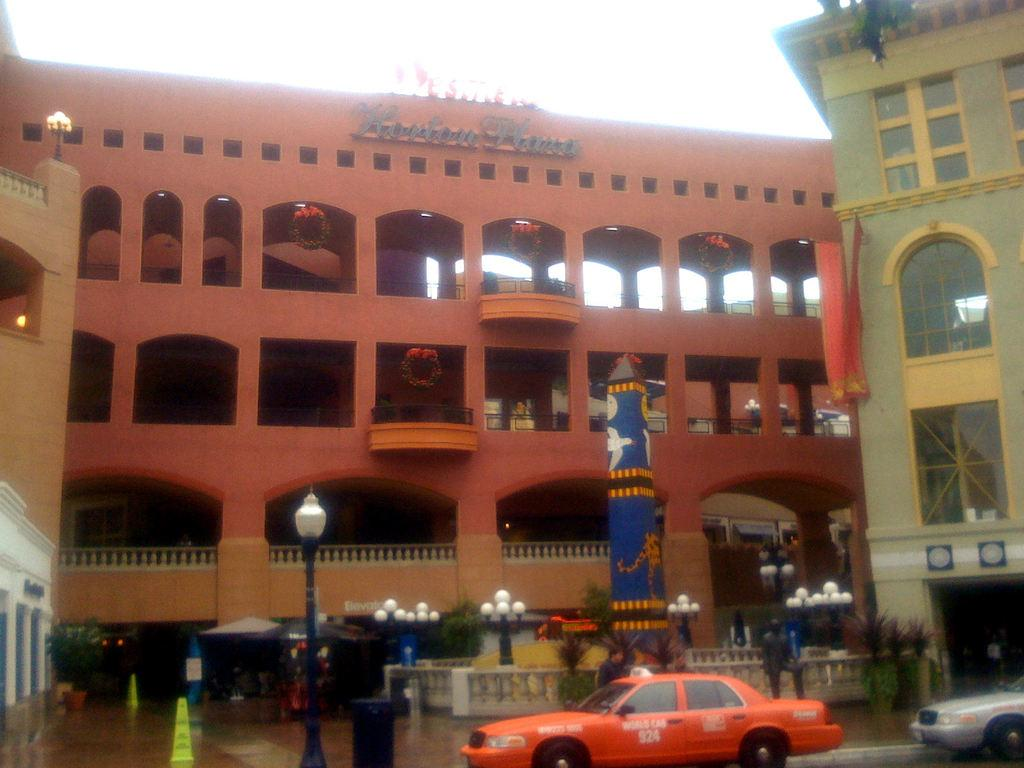<image>
Write a terse but informative summary of the picture. Cars are on the street in front of the Horton Plaza. 